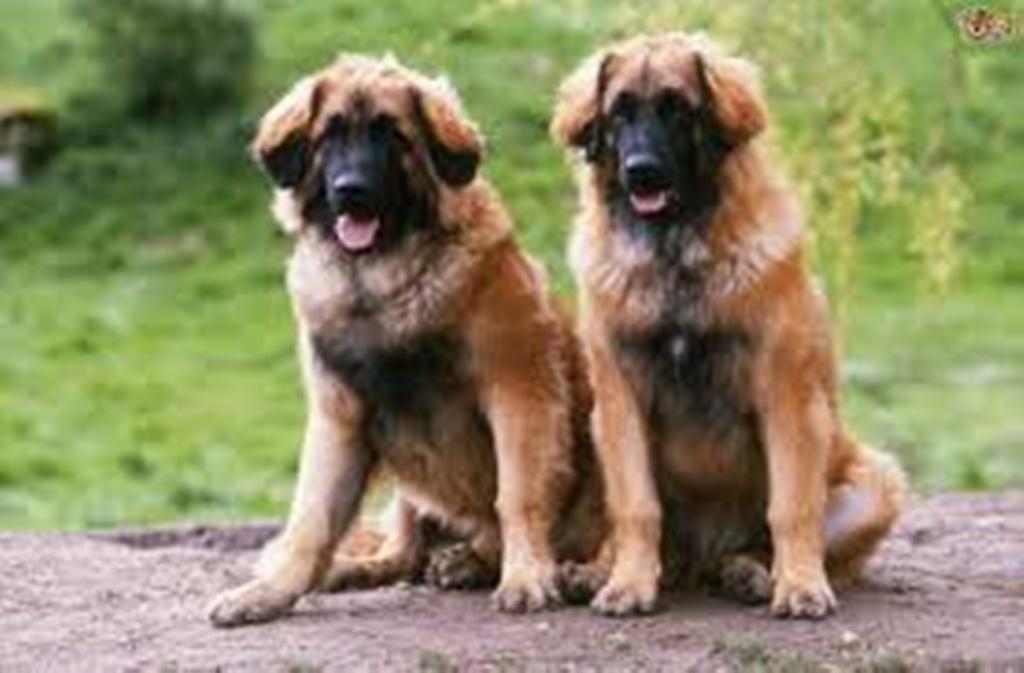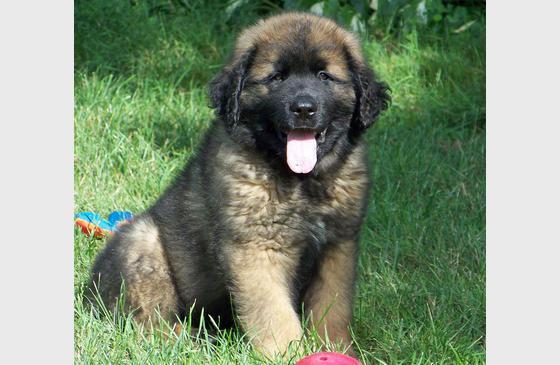The first image is the image on the left, the second image is the image on the right. Assess this claim about the two images: "Exactly one image, the one on the left, shows a dog tugging on the pocket of its handler at a dog show, and the handler is wearing a brownish-yellow necktie.". Correct or not? Answer yes or no. No. The first image is the image on the left, the second image is the image on the right. For the images shown, is this caption "There are more than two dogs visible." true? Answer yes or no. Yes. 